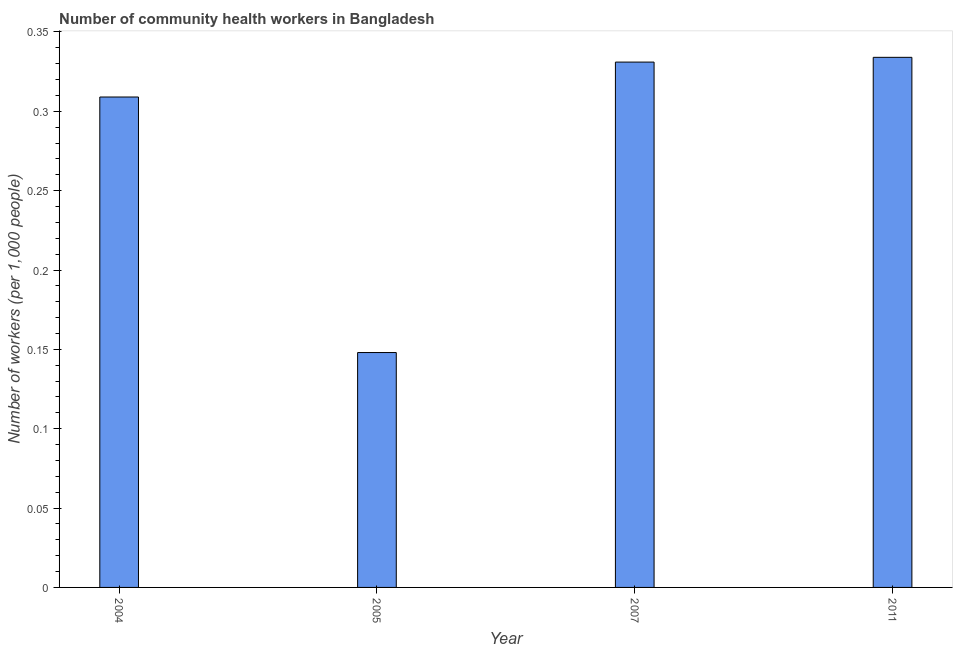Does the graph contain grids?
Your answer should be very brief. No. What is the title of the graph?
Offer a terse response. Number of community health workers in Bangladesh. What is the label or title of the X-axis?
Your response must be concise. Year. What is the label or title of the Y-axis?
Your response must be concise. Number of workers (per 1,0 people). What is the number of community health workers in 2004?
Keep it short and to the point. 0.31. Across all years, what is the maximum number of community health workers?
Offer a very short reply. 0.33. Across all years, what is the minimum number of community health workers?
Provide a succinct answer. 0.15. What is the sum of the number of community health workers?
Provide a short and direct response. 1.12. What is the difference between the number of community health workers in 2005 and 2007?
Your answer should be compact. -0.18. What is the average number of community health workers per year?
Offer a very short reply. 0.28. What is the median number of community health workers?
Offer a very short reply. 0.32. Do a majority of the years between 2007 and 2004 (inclusive) have number of community health workers greater than 0.28 ?
Offer a terse response. Yes. What is the ratio of the number of community health workers in 2004 to that in 2007?
Give a very brief answer. 0.93. What is the difference between the highest and the second highest number of community health workers?
Your answer should be very brief. 0. What is the difference between the highest and the lowest number of community health workers?
Make the answer very short. 0.19. In how many years, is the number of community health workers greater than the average number of community health workers taken over all years?
Give a very brief answer. 3. Are all the bars in the graph horizontal?
Provide a succinct answer. No. How many years are there in the graph?
Offer a terse response. 4. What is the Number of workers (per 1,000 people) of 2004?
Offer a terse response. 0.31. What is the Number of workers (per 1,000 people) in 2005?
Provide a short and direct response. 0.15. What is the Number of workers (per 1,000 people) in 2007?
Keep it short and to the point. 0.33. What is the Number of workers (per 1,000 people) in 2011?
Offer a terse response. 0.33. What is the difference between the Number of workers (per 1,000 people) in 2004 and 2005?
Provide a succinct answer. 0.16. What is the difference between the Number of workers (per 1,000 people) in 2004 and 2007?
Provide a succinct answer. -0.02. What is the difference between the Number of workers (per 1,000 people) in 2004 and 2011?
Provide a succinct answer. -0.03. What is the difference between the Number of workers (per 1,000 people) in 2005 and 2007?
Your answer should be compact. -0.18. What is the difference between the Number of workers (per 1,000 people) in 2005 and 2011?
Provide a short and direct response. -0.19. What is the difference between the Number of workers (per 1,000 people) in 2007 and 2011?
Your response must be concise. -0. What is the ratio of the Number of workers (per 1,000 people) in 2004 to that in 2005?
Give a very brief answer. 2.09. What is the ratio of the Number of workers (per 1,000 people) in 2004 to that in 2007?
Provide a short and direct response. 0.93. What is the ratio of the Number of workers (per 1,000 people) in 2004 to that in 2011?
Make the answer very short. 0.93. What is the ratio of the Number of workers (per 1,000 people) in 2005 to that in 2007?
Ensure brevity in your answer.  0.45. What is the ratio of the Number of workers (per 1,000 people) in 2005 to that in 2011?
Give a very brief answer. 0.44. 